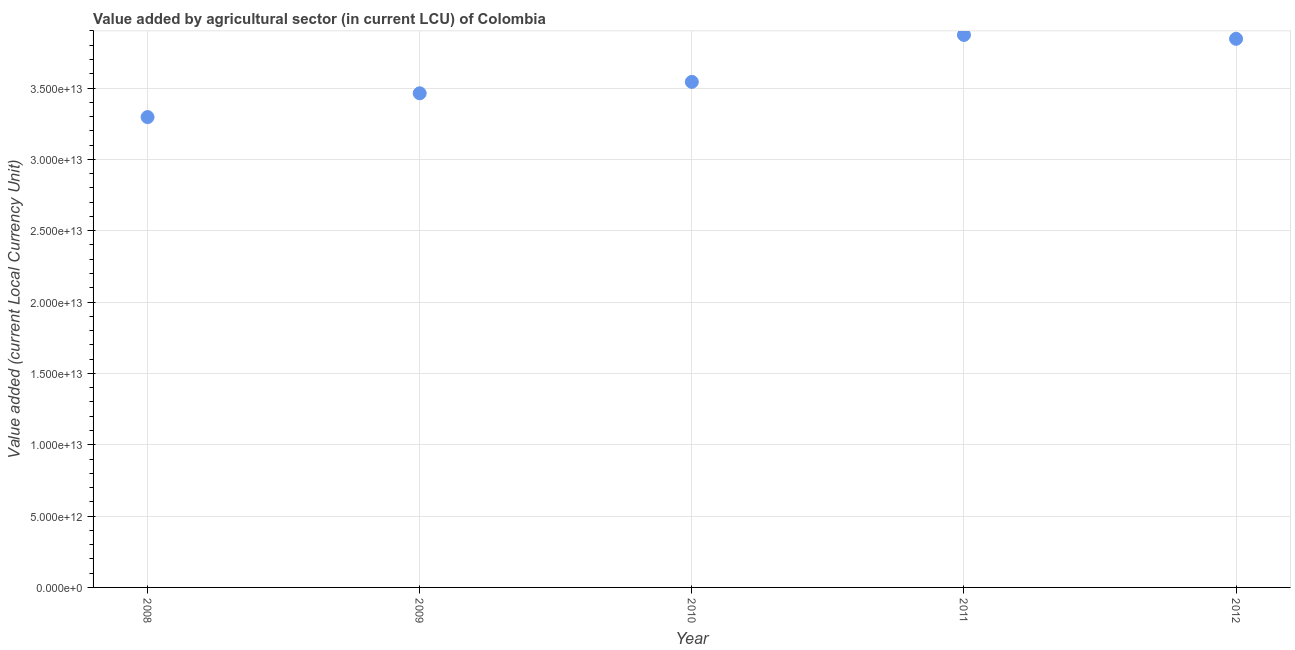What is the value added by agriculture sector in 2008?
Offer a very short reply. 3.30e+13. Across all years, what is the maximum value added by agriculture sector?
Provide a short and direct response. 3.87e+13. Across all years, what is the minimum value added by agriculture sector?
Your answer should be compact. 3.30e+13. In which year was the value added by agriculture sector maximum?
Your answer should be compact. 2011. In which year was the value added by agriculture sector minimum?
Give a very brief answer. 2008. What is the sum of the value added by agriculture sector?
Provide a short and direct response. 1.80e+14. What is the difference between the value added by agriculture sector in 2009 and 2010?
Make the answer very short. -7.99e+11. What is the average value added by agriculture sector per year?
Your answer should be very brief. 3.60e+13. What is the median value added by agriculture sector?
Provide a short and direct response. 3.54e+13. What is the ratio of the value added by agriculture sector in 2009 to that in 2011?
Keep it short and to the point. 0.89. Is the difference between the value added by agriculture sector in 2008 and 2010 greater than the difference between any two years?
Offer a very short reply. No. What is the difference between the highest and the second highest value added by agriculture sector?
Your answer should be very brief. 2.71e+11. What is the difference between the highest and the lowest value added by agriculture sector?
Your answer should be compact. 5.76e+12. Does the value added by agriculture sector monotonically increase over the years?
Your response must be concise. No. What is the difference between two consecutive major ticks on the Y-axis?
Keep it short and to the point. 5.00e+12. Are the values on the major ticks of Y-axis written in scientific E-notation?
Your answer should be very brief. Yes. What is the title of the graph?
Your response must be concise. Value added by agricultural sector (in current LCU) of Colombia. What is the label or title of the Y-axis?
Your response must be concise. Value added (current Local Currency Unit). What is the Value added (current Local Currency Unit) in 2008?
Provide a short and direct response. 3.30e+13. What is the Value added (current Local Currency Unit) in 2009?
Provide a short and direct response. 3.46e+13. What is the Value added (current Local Currency Unit) in 2010?
Make the answer very short. 3.54e+13. What is the Value added (current Local Currency Unit) in 2011?
Ensure brevity in your answer.  3.87e+13. What is the Value added (current Local Currency Unit) in 2012?
Your response must be concise. 3.85e+13. What is the difference between the Value added (current Local Currency Unit) in 2008 and 2009?
Offer a terse response. -1.67e+12. What is the difference between the Value added (current Local Currency Unit) in 2008 and 2010?
Offer a very short reply. -2.47e+12. What is the difference between the Value added (current Local Currency Unit) in 2008 and 2011?
Your answer should be very brief. -5.76e+12. What is the difference between the Value added (current Local Currency Unit) in 2008 and 2012?
Your answer should be compact. -5.49e+12. What is the difference between the Value added (current Local Currency Unit) in 2009 and 2010?
Give a very brief answer. -7.99e+11. What is the difference between the Value added (current Local Currency Unit) in 2009 and 2011?
Provide a short and direct response. -4.09e+12. What is the difference between the Value added (current Local Currency Unit) in 2009 and 2012?
Offer a very short reply. -3.82e+12. What is the difference between the Value added (current Local Currency Unit) in 2010 and 2011?
Provide a short and direct response. -3.29e+12. What is the difference between the Value added (current Local Currency Unit) in 2010 and 2012?
Your answer should be very brief. -3.02e+12. What is the difference between the Value added (current Local Currency Unit) in 2011 and 2012?
Provide a short and direct response. 2.71e+11. What is the ratio of the Value added (current Local Currency Unit) in 2008 to that in 2009?
Offer a very short reply. 0.95. What is the ratio of the Value added (current Local Currency Unit) in 2008 to that in 2010?
Offer a terse response. 0.93. What is the ratio of the Value added (current Local Currency Unit) in 2008 to that in 2011?
Ensure brevity in your answer.  0.85. What is the ratio of the Value added (current Local Currency Unit) in 2008 to that in 2012?
Ensure brevity in your answer.  0.86. What is the ratio of the Value added (current Local Currency Unit) in 2009 to that in 2011?
Offer a very short reply. 0.89. What is the ratio of the Value added (current Local Currency Unit) in 2009 to that in 2012?
Give a very brief answer. 0.9. What is the ratio of the Value added (current Local Currency Unit) in 2010 to that in 2011?
Provide a succinct answer. 0.92. What is the ratio of the Value added (current Local Currency Unit) in 2010 to that in 2012?
Provide a short and direct response. 0.92. 